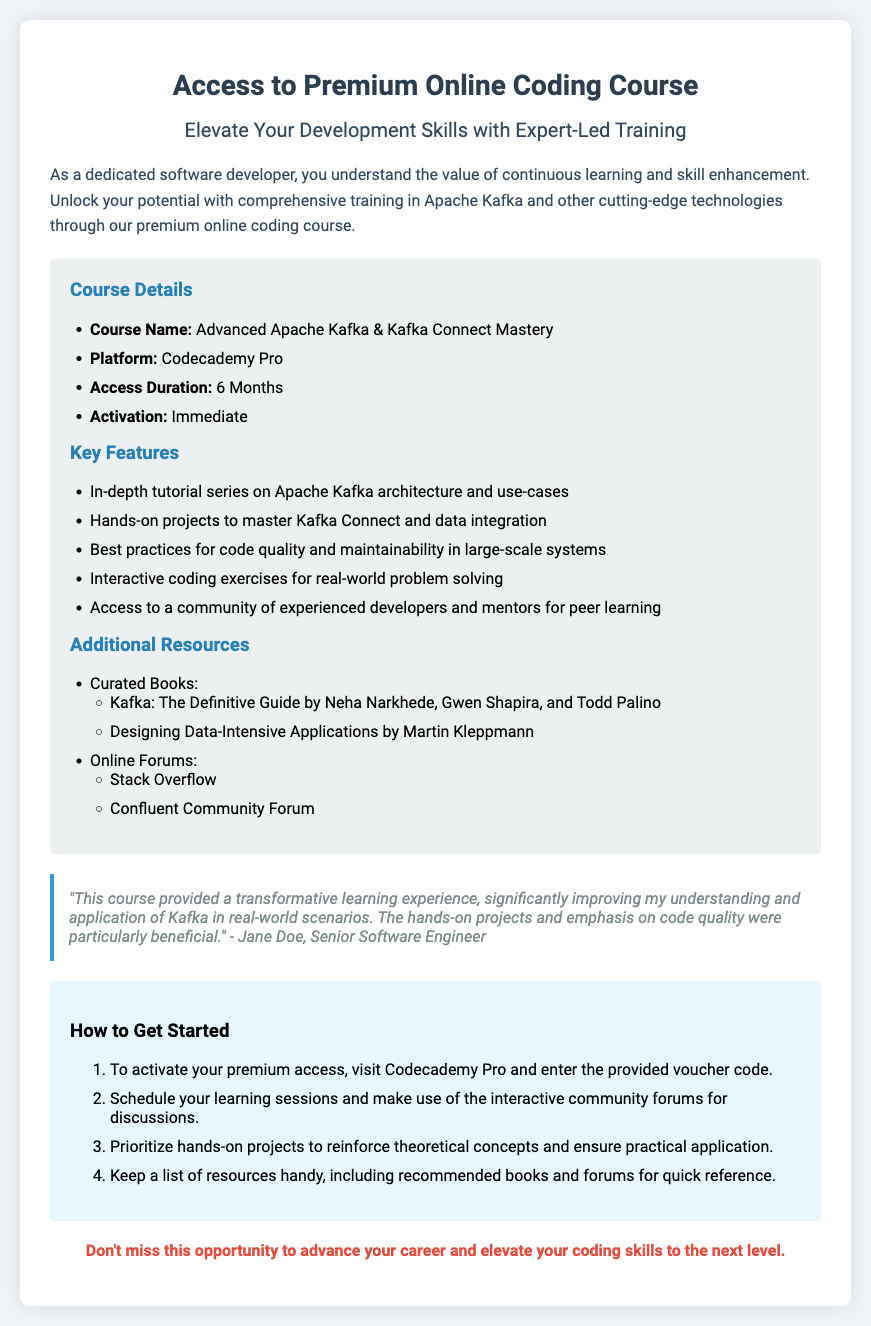What is the course name? The course name is identified in the document as part of the course details section.
Answer: Advanced Apache Kafka & Kafka Connect Mastery What is the access duration for the course? The access duration is specified clearly in the course details section of the document.
Answer: 6 Months What platform is the course offered on? This information is included under the course details in the document.
Answer: Codecademy Pro What is one key feature of the course? The document lists several key features, so any mentioned key feature is correct.
Answer: In-depth tutorial series on Apache Kafka architecture and use-cases Who provided the testimonial? The testimonial includes the name of the individual, which is mentioned at the end of the quote.
Answer: Jane Doe How do you activate your premium access? The activation process is outlined in the guidelines section of the document and is a key instruction.
Answer: Visit Codecademy Pro and enter the provided voucher code What is one resource mentioned in the additional resources section? The document lists several resources, any mentioned resource would suffice as an answer.
Answer: Kafka: The Definitive Guide by Neha Narkhede, Gwen Shapira, and Todd Palino What color is the background of the voucher? The background color is mentioned in the initial styling section of the document.
Answer: #f0f4f8 What is the color of the headings? The document specifies the color for headers, which is consistent throughout.
Answer: #2c3e50 